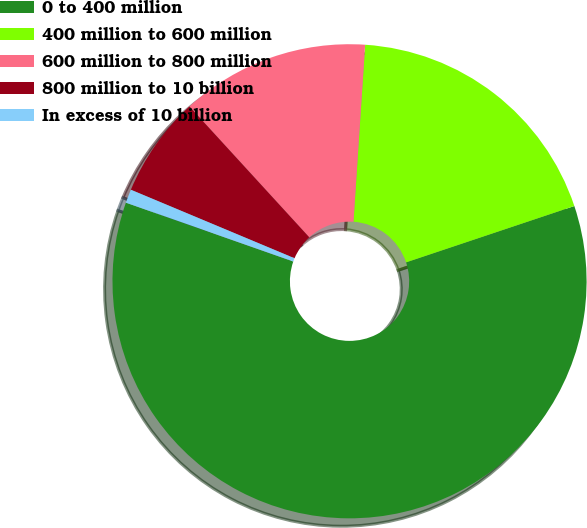<chart> <loc_0><loc_0><loc_500><loc_500><pie_chart><fcel>0 to 400 million<fcel>400 million to 600 million<fcel>600 million to 800 million<fcel>800 million to 10 billion<fcel>In excess of 10 billion<nl><fcel>60.52%<fcel>18.81%<fcel>12.85%<fcel>6.89%<fcel>0.93%<nl></chart> 